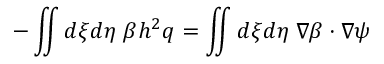<formula> <loc_0><loc_0><loc_500><loc_500>- \iint d \xi d \eta \, \beta h ^ { 2 } q = \iint d \xi d \eta \, \nabla \beta \cdot \nabla \psi</formula> 